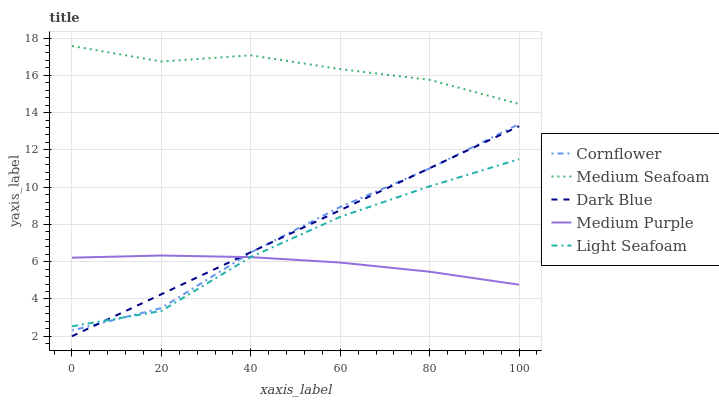Does Medium Purple have the minimum area under the curve?
Answer yes or no. Yes. Does Medium Seafoam have the maximum area under the curve?
Answer yes or no. Yes. Does Cornflower have the minimum area under the curve?
Answer yes or no. No. Does Cornflower have the maximum area under the curve?
Answer yes or no. No. Is Dark Blue the smoothest?
Answer yes or no. Yes. Is Light Seafoam the roughest?
Answer yes or no. Yes. Is Cornflower the smoothest?
Answer yes or no. No. Is Cornflower the roughest?
Answer yes or no. No. Does Dark Blue have the lowest value?
Answer yes or no. Yes. Does Cornflower have the lowest value?
Answer yes or no. No. Does Medium Seafoam have the highest value?
Answer yes or no. Yes. Does Cornflower have the highest value?
Answer yes or no. No. Is Dark Blue less than Medium Seafoam?
Answer yes or no. Yes. Is Medium Seafoam greater than Light Seafoam?
Answer yes or no. Yes. Does Medium Purple intersect Dark Blue?
Answer yes or no. Yes. Is Medium Purple less than Dark Blue?
Answer yes or no. No. Is Medium Purple greater than Dark Blue?
Answer yes or no. No. Does Dark Blue intersect Medium Seafoam?
Answer yes or no. No. 